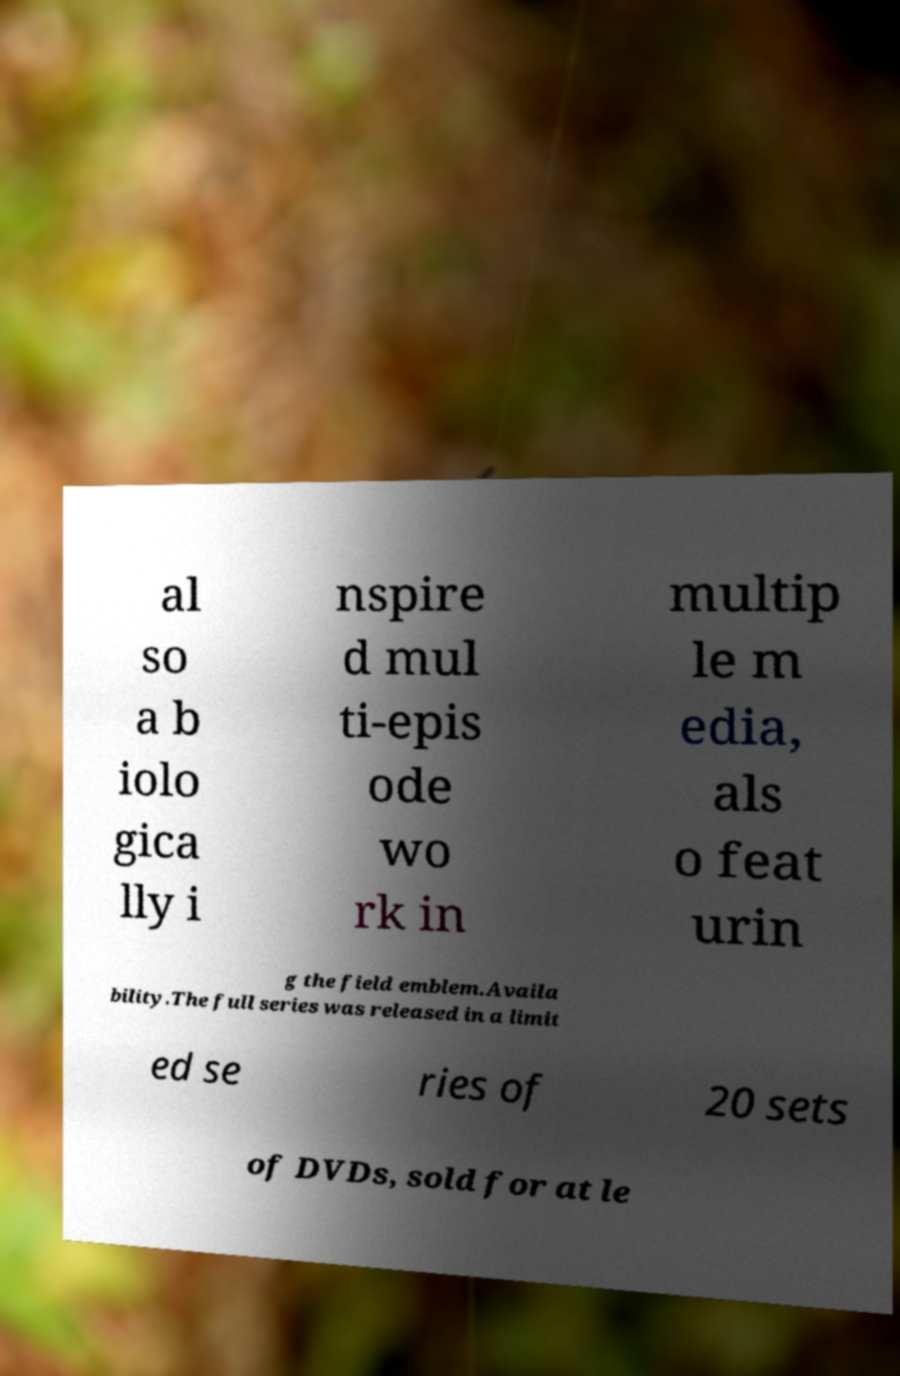Please identify and transcribe the text found in this image. al so a b iolo gica lly i nspire d mul ti-epis ode wo rk in multip le m edia, als o feat urin g the field emblem.Availa bility.The full series was released in a limit ed se ries of 20 sets of DVDs, sold for at le 